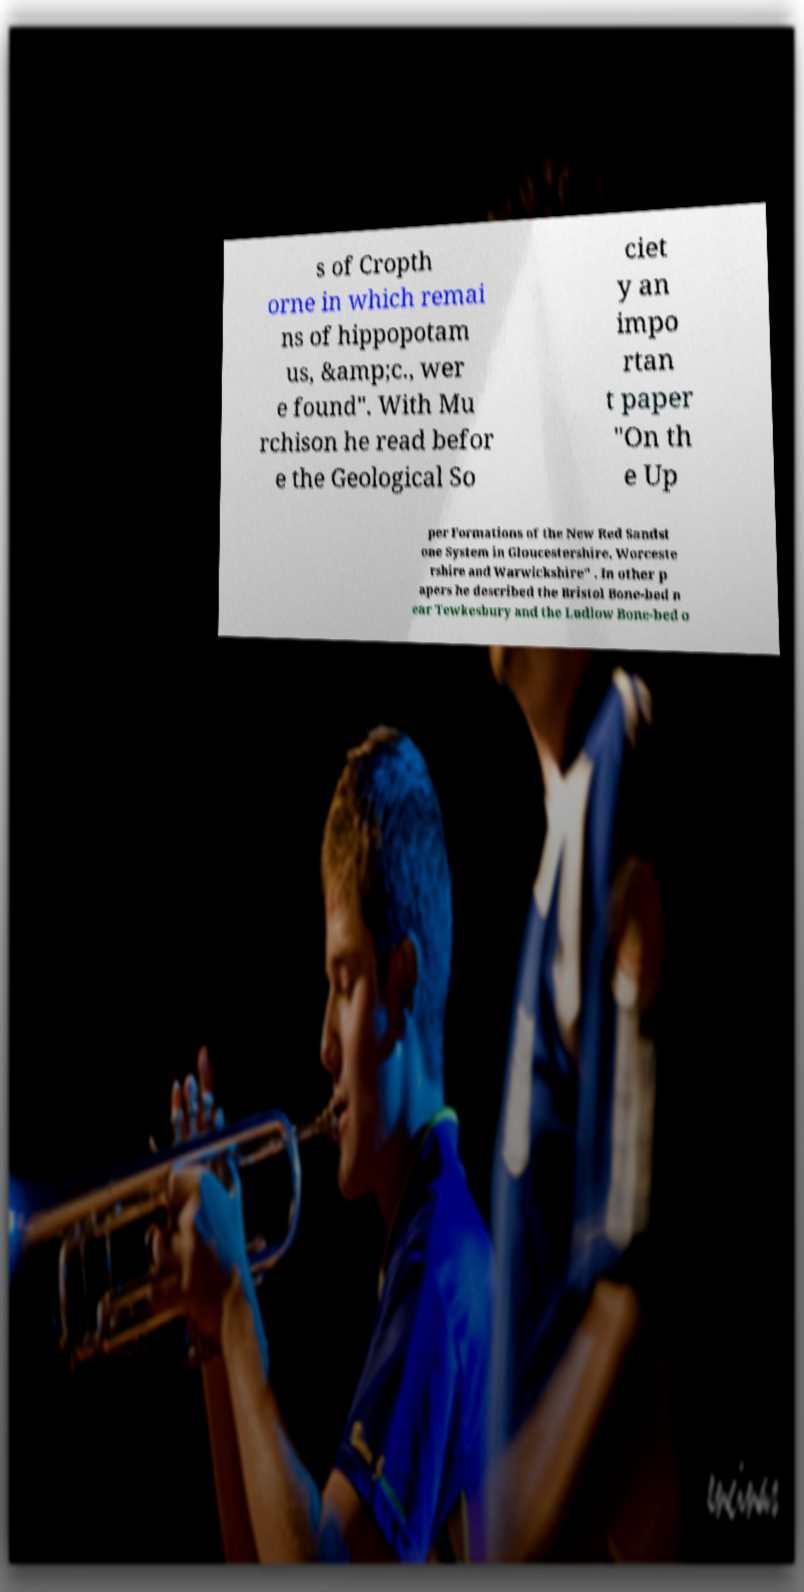Please read and relay the text visible in this image. What does it say? s of Cropth orne in which remai ns of hippopotam us, &amp;c., wer e found". With Mu rchison he read befor e the Geological So ciet y an impo rtan t paper "On th e Up per Formations of the New Red Sandst one System in Gloucestershire, Worceste rshire and Warwickshire" . In other p apers he described the Bristol Bone-bed n ear Tewkesbury and the Ludlow Bone-bed o 